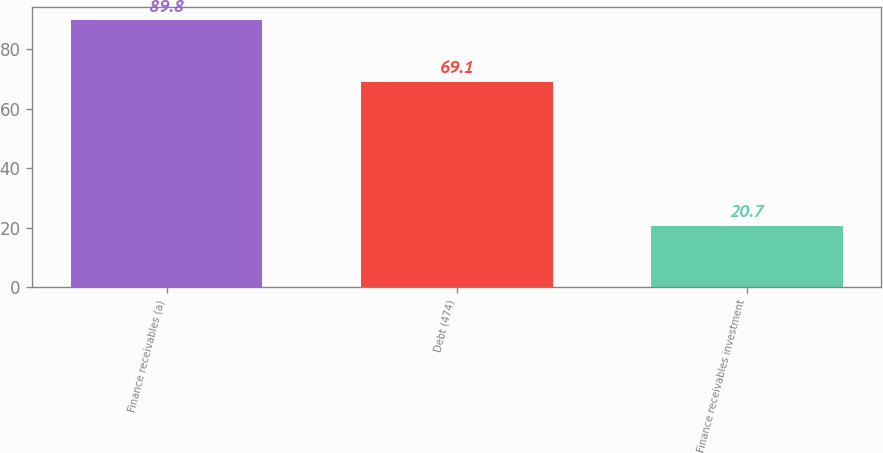<chart> <loc_0><loc_0><loc_500><loc_500><bar_chart><fcel>Finance receivables (a)<fcel>Debt (474)<fcel>Finance receivables investment<nl><fcel>89.8<fcel>69.1<fcel>20.7<nl></chart> 